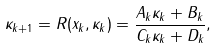Convert formula to latex. <formula><loc_0><loc_0><loc_500><loc_500>\kappa _ { k + 1 } = R ( x _ { k } , \kappa _ { k } ) = \frac { A _ { k } \kappa _ { k } + B _ { k } } { C _ { k } \kappa _ { k } + D _ { k } } ,</formula> 